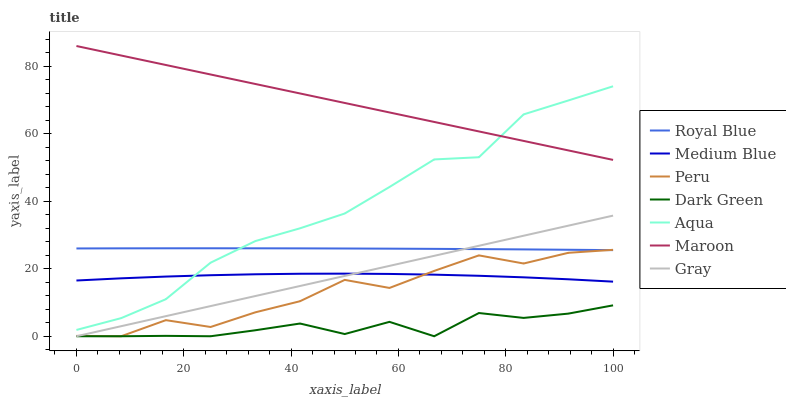Does Dark Green have the minimum area under the curve?
Answer yes or no. Yes. Does Maroon have the maximum area under the curve?
Answer yes or no. Yes. Does Medium Blue have the minimum area under the curve?
Answer yes or no. No. Does Medium Blue have the maximum area under the curve?
Answer yes or no. No. Is Gray the smoothest?
Answer yes or no. Yes. Is Peru the roughest?
Answer yes or no. Yes. Is Medium Blue the smoothest?
Answer yes or no. No. Is Medium Blue the roughest?
Answer yes or no. No. Does Gray have the lowest value?
Answer yes or no. Yes. Does Medium Blue have the lowest value?
Answer yes or no. No. Does Maroon have the highest value?
Answer yes or no. Yes. Does Medium Blue have the highest value?
Answer yes or no. No. Is Dark Green less than Medium Blue?
Answer yes or no. Yes. Is Aqua greater than Gray?
Answer yes or no. Yes. Does Aqua intersect Medium Blue?
Answer yes or no. Yes. Is Aqua less than Medium Blue?
Answer yes or no. No. Is Aqua greater than Medium Blue?
Answer yes or no. No. Does Dark Green intersect Medium Blue?
Answer yes or no. No. 